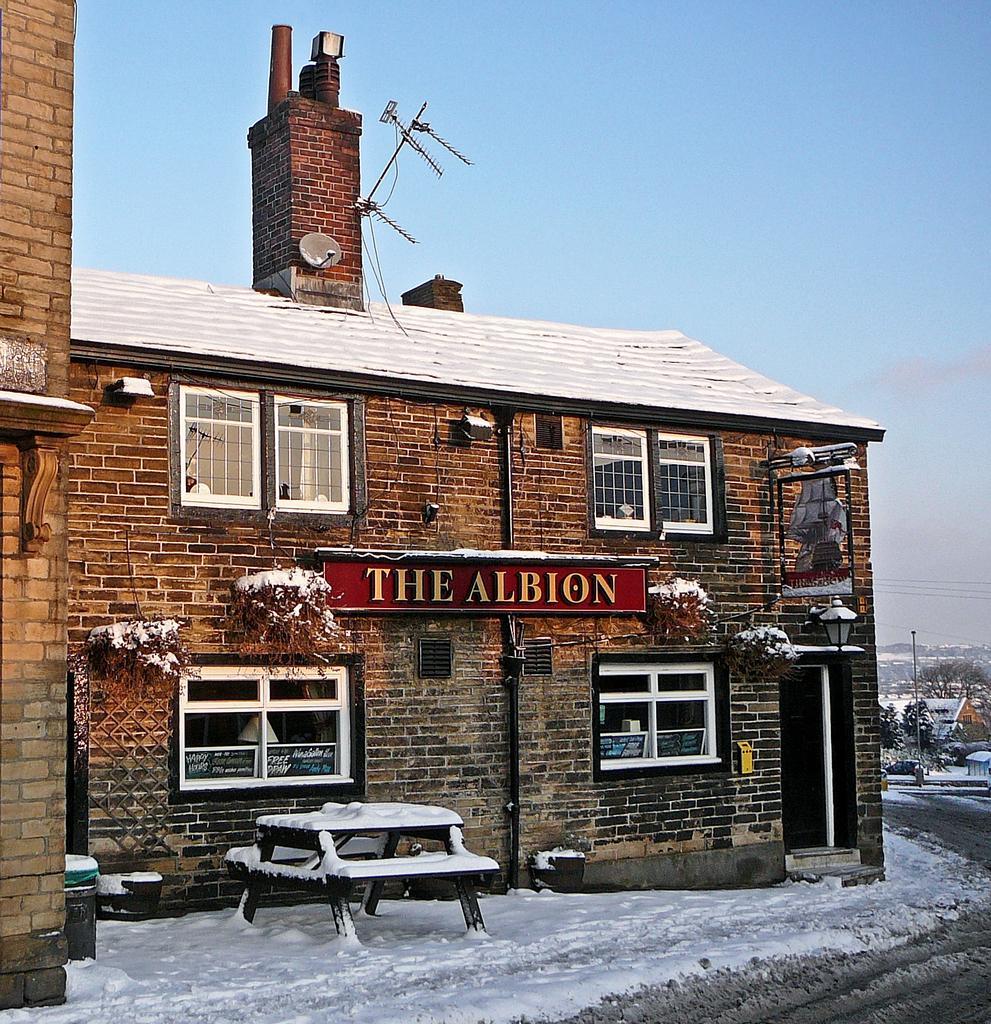Please provide a concise description of this image. In this picture there is a building which has the albion written on it and there is a chimney above the building and there is a table in front of it which is covered with snow and there are few buildings and trees in the right corner. 